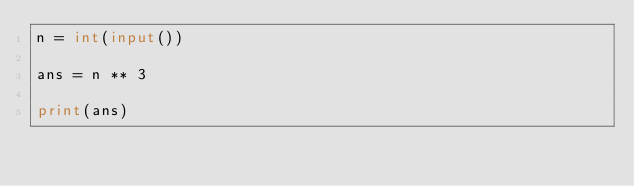<code> <loc_0><loc_0><loc_500><loc_500><_Python_>n = int(input())

ans = n ** 3

print(ans)</code> 